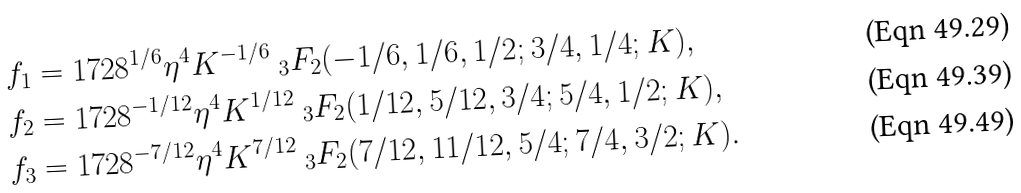<formula> <loc_0><loc_0><loc_500><loc_500>f _ { 1 } & = 1 7 2 8 ^ { 1 / 6 } \eta ^ { 4 } K ^ { - 1 / 6 } \ _ { 3 } F _ { 2 } ( - 1 / 6 , 1 / 6 , 1 / 2 ; 3 / 4 , 1 / 4 ; K ) , \\ f _ { 2 } & = 1 7 2 8 ^ { - 1 / 1 2 } \eta ^ { 4 } K ^ { 1 / 1 2 } \ _ { 3 } F _ { 2 } ( 1 / 1 2 , 5 / 1 2 , 3 / 4 ; 5 / 4 , 1 / 2 ; K ) , \\ f _ { 3 } & = 1 7 2 8 ^ { - 7 / 1 2 } \eta ^ { 4 } K ^ { 7 / 1 2 } \ _ { 3 } F _ { 2 } ( 7 / 1 2 , 1 1 / 1 2 , 5 / 4 ; 7 / 4 , 3 / 2 ; K ) .</formula> 